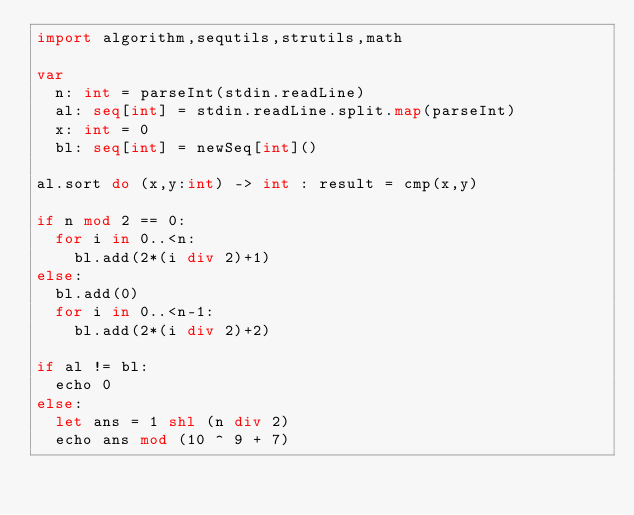Convert code to text. <code><loc_0><loc_0><loc_500><loc_500><_Nim_>import algorithm,sequtils,strutils,math

var
  n: int = parseInt(stdin.readLine)
  al: seq[int] = stdin.readLine.split.map(parseInt)  
  x: int = 0
  bl: seq[int] = newSeq[int]()

al.sort do (x,y:int) -> int : result = cmp(x,y)

if n mod 2 == 0:
  for i in 0..<n:
    bl.add(2*(i div 2)+1)
else:
  bl.add(0)
  for i in 0..<n-1:
    bl.add(2*(i div 2)+2)
    
if al != bl:
  echo 0
else:
  let ans = 1 shl (n div 2)
  echo ans mod (10 ^ 9 + 7)</code> 